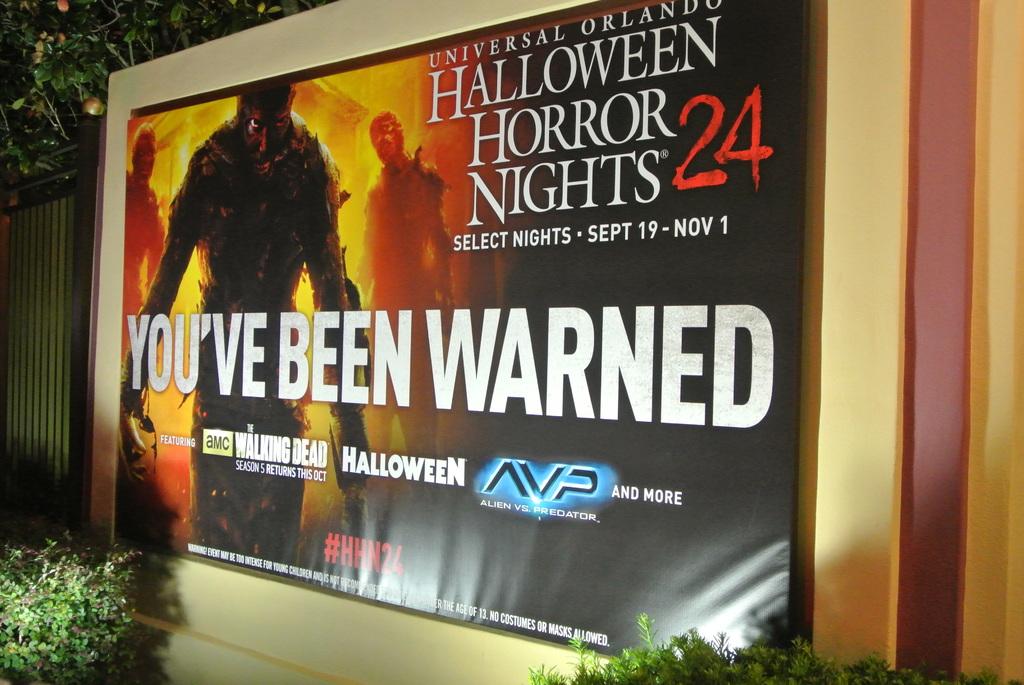Which universal is it?
Provide a short and direct response. Orlando. Who has been warned?
Ensure brevity in your answer.  You've. 